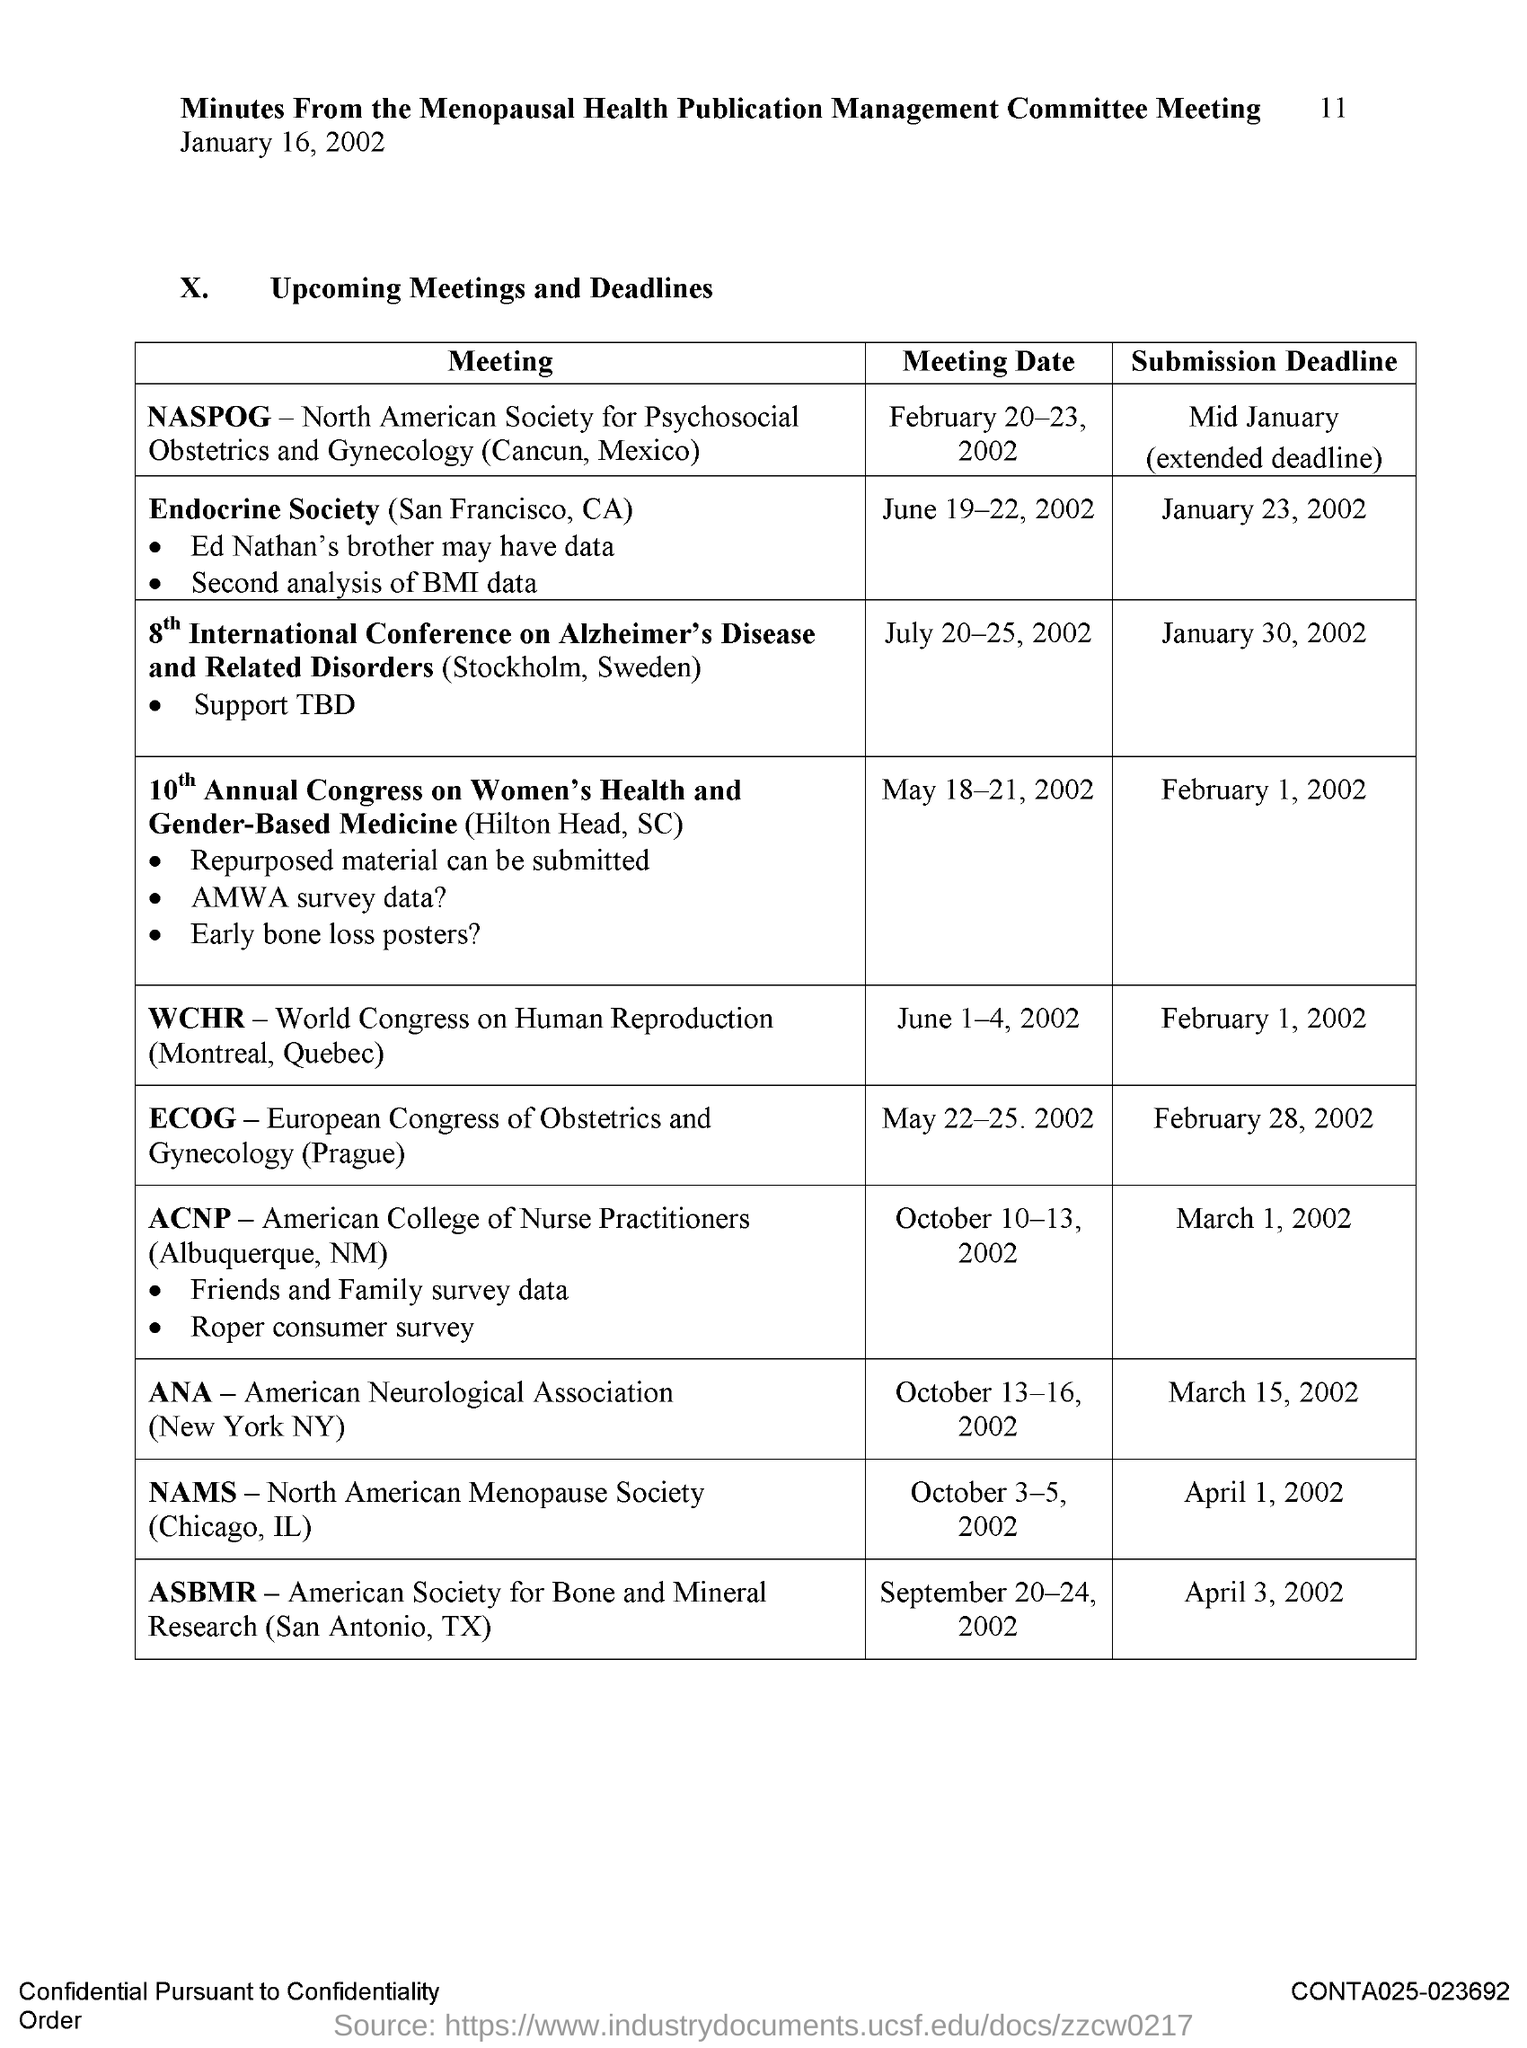Outline some significant characteristics in this image. The full form of ANA is American Neurological Association. The full form of WCHR is World Congress on Human Reproduction. The acronym "NAMS" stands for the North American Menopause Society, an organization dedicated to understanding and addressing the various aspects of menopause in women. 